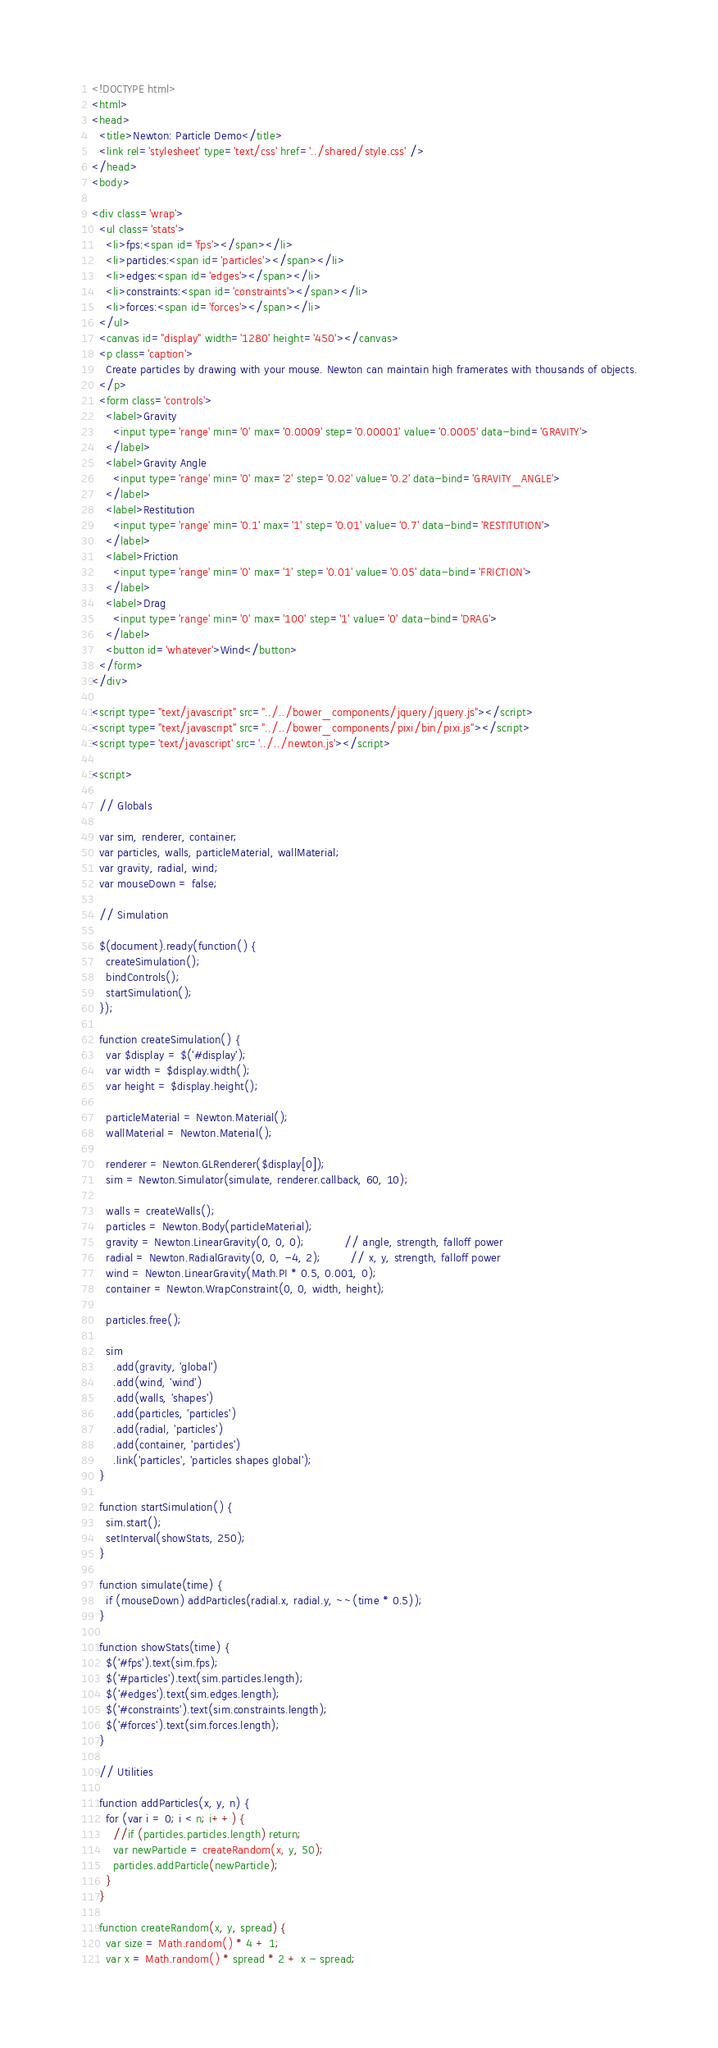<code> <loc_0><loc_0><loc_500><loc_500><_HTML_><!DOCTYPE html>
<html>
<head>
  <title>Newton: Particle Demo</title>
  <link rel='stylesheet' type='text/css' href='../shared/style.css' />
</head>
<body>

<div class='wrap'>
  <ul class='stats'>
    <li>fps:<span id='fps'></span></li>
    <li>particles:<span id='particles'></span></li>
    <li>edges:<span id='edges'></span></li>
    <li>constraints:<span id='constraints'></span></li>
    <li>forces:<span id='forces'></span></li>
  </ul>
  <canvas id="display" width='1280' height='450'></canvas>
  <p class='caption'>
    Create particles by drawing with your mouse. Newton can maintain high framerates with thousands of objects.
  </p>
  <form class='controls'>
    <label>Gravity
      <input type='range' min='0' max='0.0009' step='0.00001' value='0.0005' data-bind='GRAVITY'>
    </label>
    <label>Gravity Angle
      <input type='range' min='0' max='2' step='0.02' value='0.2' data-bind='GRAVITY_ANGLE'>
    </label>
    <label>Restitution
      <input type='range' min='0.1' max='1' step='0.01' value='0.7' data-bind='RESTITUTION'>
    </label>
    <label>Friction
      <input type='range' min='0' max='1' step='0.01' value='0.05' data-bind='FRICTION'>
    </label>
    <label>Drag
      <input type='range' min='0' max='100' step='1' value='0' data-bind='DRAG'>
    </label>
    <button id='whatever'>Wind</button>
  </form>
</div>

<script type="text/javascript" src="../../bower_components/jquery/jquery.js"></script>
<script type="text/javascript" src="../../bower_components/pixi/bin/pixi.js"></script>
<script type='text/javascript' src='../../newton.js'></script>

<script>

  // Globals

  var sim, renderer, container;
  var particles, walls, particleMaterial, wallMaterial;
  var gravity, radial, wind;
  var mouseDown = false;

  // Simulation

  $(document).ready(function() {
    createSimulation();
    bindControls();
    startSimulation();
  });

  function createSimulation() {
    var $display = $('#display');
    var width = $display.width();
    var height = $display.height();

    particleMaterial = Newton.Material();
    wallMaterial = Newton.Material();

    renderer = Newton.GLRenderer($display[0]);
    sim = Newton.Simulator(simulate, renderer.callback, 60, 10);

    walls = createWalls();
    particles = Newton.Body(particleMaterial);
    gravity = Newton.LinearGravity(0, 0, 0);           // angle, strength, falloff power
    radial = Newton.RadialGravity(0, 0, -4, 2);        // x, y, strength, falloff power
    wind = Newton.LinearGravity(Math.PI * 0.5, 0.001, 0);
    container = Newton.WrapConstraint(0, 0, width, height);

    particles.free();

    sim
      .add(gravity, 'global')
      .add(wind, 'wind')
      .add(walls, 'shapes')
      .add(particles, 'particles')
      .add(radial, 'particles')
      .add(container, 'particles')
      .link('particles', 'particles shapes global');
  }

  function startSimulation() {
    sim.start();
    setInterval(showStats, 250);
  }

  function simulate(time) {
    if (mouseDown) addParticles(radial.x, radial.y, ~~(time * 0.5));
  }

  function showStats(time) {
    $('#fps').text(sim.fps);
    $('#particles').text(sim.particles.length);
    $('#edges').text(sim.edges.length);
    $('#constraints').text(sim.constraints.length);
    $('#forces').text(sim.forces.length);
  }

  // Utilities

  function addParticles(x, y, n) {
    for (var i = 0; i < n; i++) {
      //if (particles.particles.length) return;
      var newParticle = createRandom(x, y, 50);
      particles.addParticle(newParticle);
    }
  }

  function createRandom(x, y, spread) {
    var size = Math.random() * 4 + 1;
    var x = Math.random() * spread * 2 + x - spread;</code> 